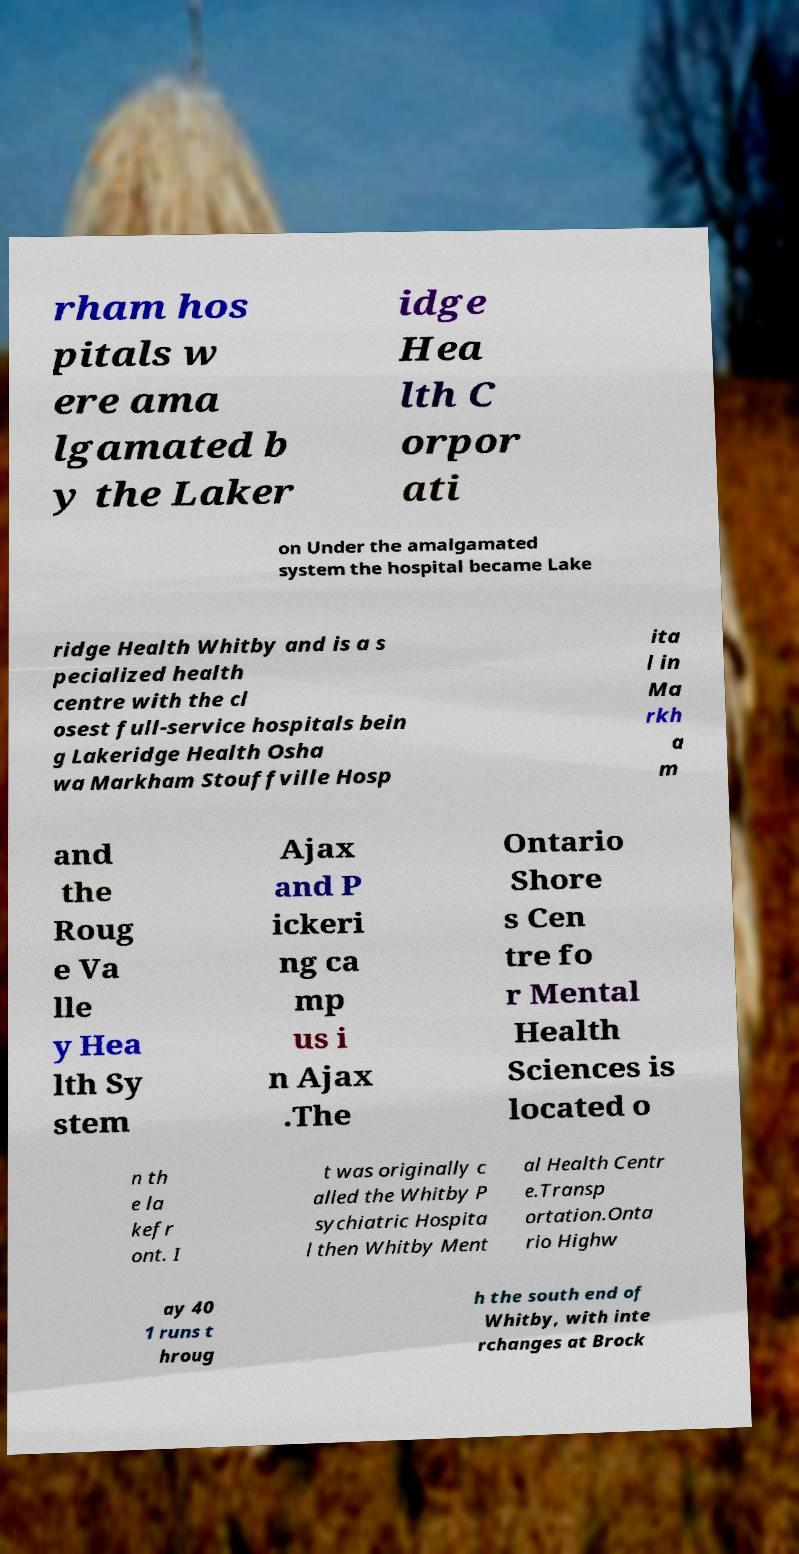Could you assist in decoding the text presented in this image and type it out clearly? rham hos pitals w ere ama lgamated b y the Laker idge Hea lth C orpor ati on Under the amalgamated system the hospital became Lake ridge Health Whitby and is a s pecialized health centre with the cl osest full-service hospitals bein g Lakeridge Health Osha wa Markham Stouffville Hosp ita l in Ma rkh a m and the Roug e Va lle y Hea lth Sy stem Ajax and P ickeri ng ca mp us i n Ajax .The Ontario Shore s Cen tre fo r Mental Health Sciences is located o n th e la kefr ont. I t was originally c alled the Whitby P sychiatric Hospita l then Whitby Ment al Health Centr e.Transp ortation.Onta rio Highw ay 40 1 runs t hroug h the south end of Whitby, with inte rchanges at Brock 